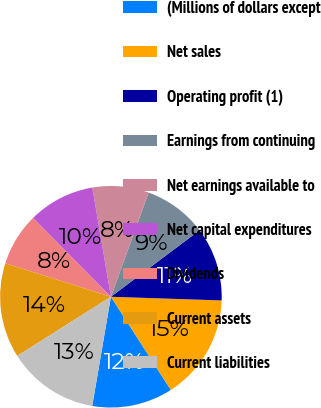<chart> <loc_0><loc_0><loc_500><loc_500><pie_chart><fcel>(Millions of dollars except<fcel>Net sales<fcel>Operating profit (1)<fcel>Earnings from continuing<fcel>Net earnings available to<fcel>Net capital expenditures<fcel>Dividends<fcel>Current assets<fcel>Current liabilities<nl><fcel>11.79%<fcel>15.38%<fcel>10.77%<fcel>9.23%<fcel>8.21%<fcel>9.74%<fcel>7.69%<fcel>13.85%<fcel>13.33%<nl></chart> 